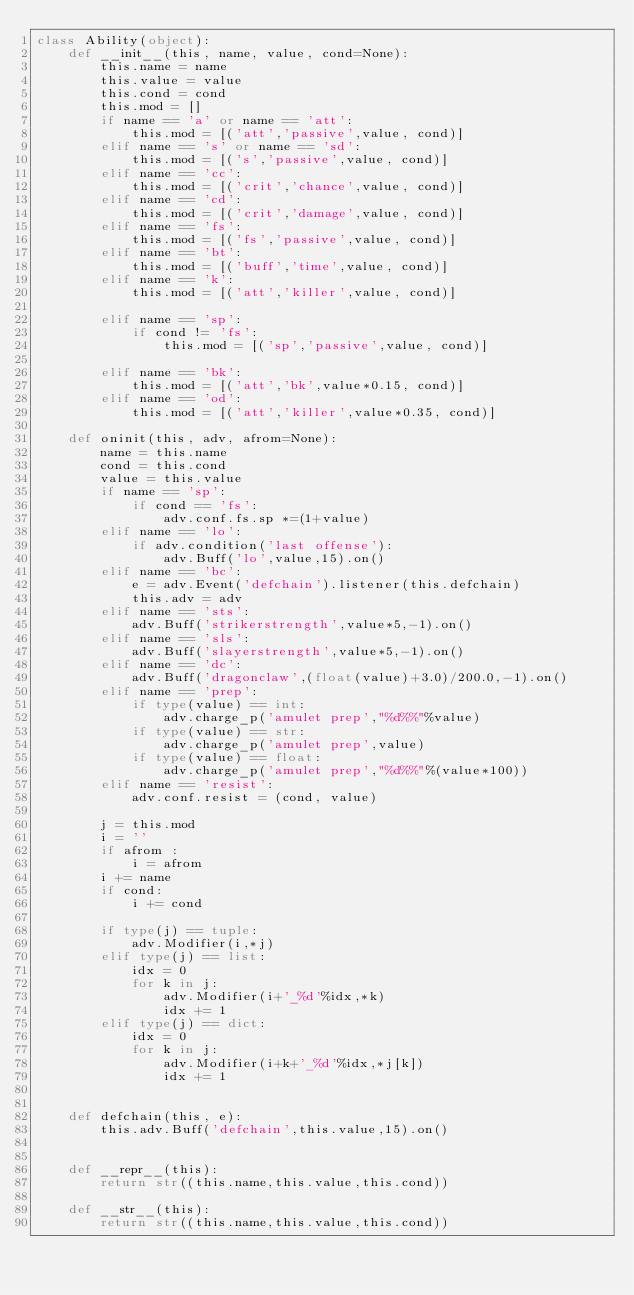Convert code to text. <code><loc_0><loc_0><loc_500><loc_500><_Python_>class Ability(object):
    def __init__(this, name, value, cond=None):
        this.name = name
        this.value = value
        this.cond = cond
        this.mod = []
        if name == 'a' or name == 'att':
            this.mod = [('att','passive',value, cond)]
        elif name == 's' or name == 'sd':
            this.mod = [('s','passive',value, cond)]
        elif name == 'cc':
            this.mod = [('crit','chance',value, cond)]
        elif name == 'cd':
            this.mod = [('crit','damage',value, cond)]
        elif name == 'fs':
            this.mod = [('fs','passive',value, cond)]
        elif name == 'bt':
            this.mod = [('buff','time',value, cond)]
        elif name == 'k':
            this.mod = [('att','killer',value, cond)]

        elif name == 'sp':
            if cond != 'fs':
                this.mod = [('sp','passive',value, cond)]

        elif name == 'bk':
            this.mod = [('att','bk',value*0.15, cond)]
        elif name == 'od':
            this.mod = [('att','killer',value*0.35, cond)]

    def oninit(this, adv, afrom=None):
        name = this.name
        cond = this.cond
        value = this.value
        if name == 'sp':
            if cond == 'fs':
                adv.conf.fs.sp *=(1+value)
        elif name == 'lo':
            if adv.condition('last offense'):
                adv.Buff('lo',value,15).on()
        elif name == 'bc':
            e = adv.Event('defchain').listener(this.defchain)
            this.adv = adv
        elif name == 'sts':
            adv.Buff('strikerstrength',value*5,-1).on()
        elif name == 'sls':
            adv.Buff('slayerstrength',value*5,-1).on()
        elif name == 'dc':
            adv.Buff('dragonclaw',(float(value)+3.0)/200.0,-1).on()
        elif name == 'prep':
            if type(value) == int:
                adv.charge_p('amulet prep',"%d%%"%value)
            if type(value) == str:
                adv.charge_p('amulet prep',value)
            if type(value) == float:
                adv.charge_p('amulet prep',"%d%%"%(value*100))
        elif name == 'resist':
            adv.conf.resist = (cond, value)

        j = this.mod
        i = ''
        if afrom :
            i = afrom
        i += name
        if cond:
            i += cond

        if type(j) == tuple:
            adv.Modifier(i,*j)
        elif type(j) == list:
            idx = 0
            for k in j:
                adv.Modifier(i+'_%d'%idx,*k)
                idx += 1
        elif type(j) == dict:
            idx = 0
            for k in j:
                adv.Modifier(i+k+'_%d'%idx,*j[k])
                idx += 1


    def defchain(this, e):
        this.adv.Buff('defchain',this.value,15).on()


    def __repr__(this):
        return str((this.name,this.value,this.cond))

    def __str__(this):
        return str((this.name,this.value,this.cond))

</code> 